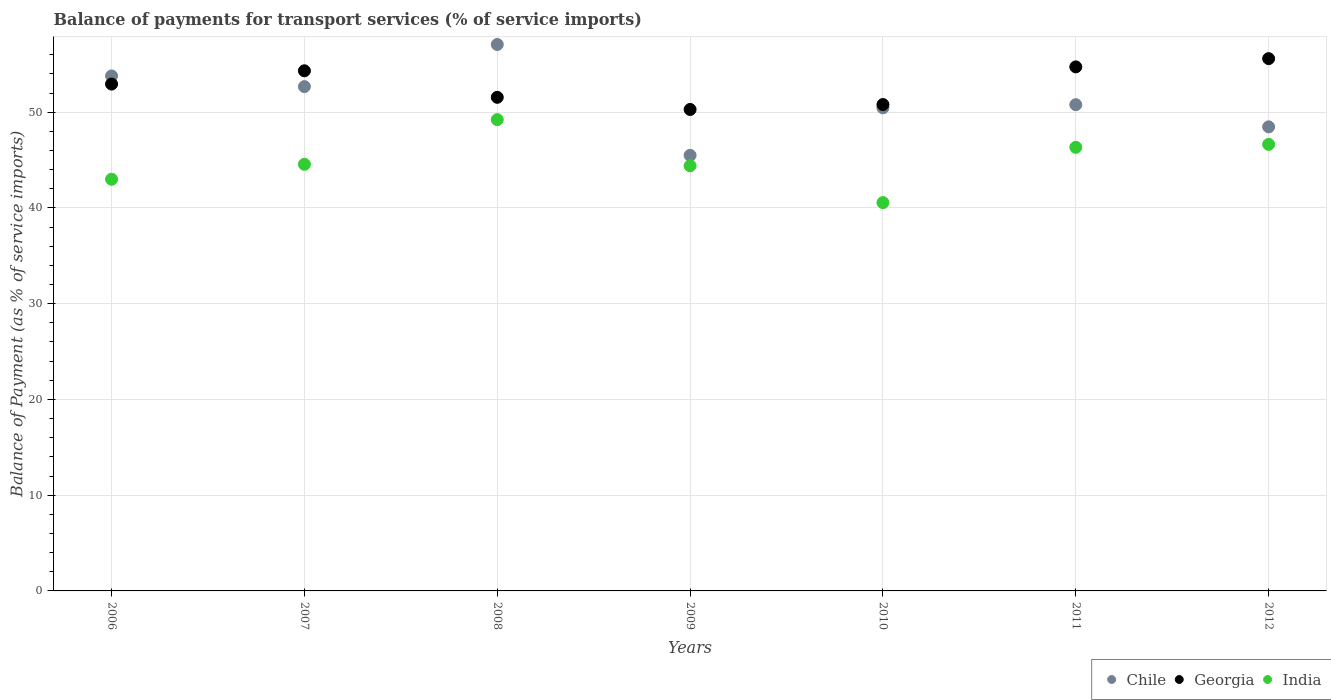How many different coloured dotlines are there?
Keep it short and to the point. 3. Is the number of dotlines equal to the number of legend labels?
Ensure brevity in your answer.  Yes. What is the balance of payments for transport services in Georgia in 2006?
Your answer should be compact. 52.94. Across all years, what is the maximum balance of payments for transport services in Chile?
Offer a terse response. 57.07. Across all years, what is the minimum balance of payments for transport services in Georgia?
Make the answer very short. 50.28. In which year was the balance of payments for transport services in Chile minimum?
Your answer should be compact. 2009. What is the total balance of payments for transport services in India in the graph?
Offer a very short reply. 314.7. What is the difference between the balance of payments for transport services in India in 2006 and that in 2011?
Make the answer very short. -3.33. What is the difference between the balance of payments for transport services in India in 2011 and the balance of payments for transport services in Georgia in 2012?
Provide a short and direct response. -9.26. What is the average balance of payments for transport services in Georgia per year?
Offer a terse response. 52.89. In the year 2010, what is the difference between the balance of payments for transport services in India and balance of payments for transport services in Georgia?
Provide a succinct answer. -10.24. In how many years, is the balance of payments for transport services in India greater than 6 %?
Provide a succinct answer. 7. What is the ratio of the balance of payments for transport services in India in 2009 to that in 2011?
Provide a succinct answer. 0.96. What is the difference between the highest and the second highest balance of payments for transport services in Chile?
Offer a terse response. 3.29. What is the difference between the highest and the lowest balance of payments for transport services in Chile?
Your answer should be compact. 11.58. Is the sum of the balance of payments for transport services in India in 2006 and 2011 greater than the maximum balance of payments for transport services in Georgia across all years?
Make the answer very short. Yes. Does the balance of payments for transport services in India monotonically increase over the years?
Provide a succinct answer. No. Is the balance of payments for transport services in Chile strictly greater than the balance of payments for transport services in Georgia over the years?
Offer a terse response. No. Is the balance of payments for transport services in India strictly less than the balance of payments for transport services in Chile over the years?
Ensure brevity in your answer.  Yes. How many dotlines are there?
Provide a succinct answer. 3. How many years are there in the graph?
Offer a very short reply. 7. What is the difference between two consecutive major ticks on the Y-axis?
Offer a terse response. 10. Are the values on the major ticks of Y-axis written in scientific E-notation?
Provide a short and direct response. No. Does the graph contain grids?
Provide a short and direct response. Yes. How are the legend labels stacked?
Give a very brief answer. Horizontal. What is the title of the graph?
Keep it short and to the point. Balance of payments for transport services (% of service imports). Does "Uganda" appear as one of the legend labels in the graph?
Give a very brief answer. No. What is the label or title of the X-axis?
Provide a succinct answer. Years. What is the label or title of the Y-axis?
Provide a succinct answer. Balance of Payment (as % of service imports). What is the Balance of Payment (as % of service imports) of Chile in 2006?
Ensure brevity in your answer.  53.79. What is the Balance of Payment (as % of service imports) in Georgia in 2006?
Offer a very short reply. 52.94. What is the Balance of Payment (as % of service imports) of India in 2006?
Provide a short and direct response. 43. What is the Balance of Payment (as % of service imports) of Chile in 2007?
Keep it short and to the point. 52.67. What is the Balance of Payment (as % of service imports) of Georgia in 2007?
Ensure brevity in your answer.  54.32. What is the Balance of Payment (as % of service imports) of India in 2007?
Provide a short and direct response. 44.56. What is the Balance of Payment (as % of service imports) of Chile in 2008?
Your answer should be very brief. 57.07. What is the Balance of Payment (as % of service imports) of Georgia in 2008?
Offer a very short reply. 51.55. What is the Balance of Payment (as % of service imports) of India in 2008?
Your answer should be very brief. 49.22. What is the Balance of Payment (as % of service imports) in Chile in 2009?
Your answer should be very brief. 45.49. What is the Balance of Payment (as % of service imports) of Georgia in 2009?
Keep it short and to the point. 50.28. What is the Balance of Payment (as % of service imports) in India in 2009?
Your answer should be compact. 44.4. What is the Balance of Payment (as % of service imports) in Chile in 2010?
Offer a terse response. 50.45. What is the Balance of Payment (as % of service imports) of Georgia in 2010?
Offer a very short reply. 50.8. What is the Balance of Payment (as % of service imports) of India in 2010?
Make the answer very short. 40.56. What is the Balance of Payment (as % of service imports) of Chile in 2011?
Give a very brief answer. 50.78. What is the Balance of Payment (as % of service imports) of Georgia in 2011?
Your response must be concise. 54.73. What is the Balance of Payment (as % of service imports) of India in 2011?
Ensure brevity in your answer.  46.33. What is the Balance of Payment (as % of service imports) of Chile in 2012?
Provide a succinct answer. 48.47. What is the Balance of Payment (as % of service imports) of Georgia in 2012?
Provide a succinct answer. 55.59. What is the Balance of Payment (as % of service imports) in India in 2012?
Provide a short and direct response. 46.64. Across all years, what is the maximum Balance of Payment (as % of service imports) in Chile?
Provide a short and direct response. 57.07. Across all years, what is the maximum Balance of Payment (as % of service imports) of Georgia?
Your answer should be compact. 55.59. Across all years, what is the maximum Balance of Payment (as % of service imports) of India?
Keep it short and to the point. 49.22. Across all years, what is the minimum Balance of Payment (as % of service imports) of Chile?
Your response must be concise. 45.49. Across all years, what is the minimum Balance of Payment (as % of service imports) in Georgia?
Offer a terse response. 50.28. Across all years, what is the minimum Balance of Payment (as % of service imports) of India?
Provide a short and direct response. 40.56. What is the total Balance of Payment (as % of service imports) of Chile in the graph?
Your response must be concise. 358.72. What is the total Balance of Payment (as % of service imports) of Georgia in the graph?
Your answer should be compact. 370.22. What is the total Balance of Payment (as % of service imports) of India in the graph?
Your answer should be compact. 314.7. What is the difference between the Balance of Payment (as % of service imports) of Chile in 2006 and that in 2007?
Provide a short and direct response. 1.11. What is the difference between the Balance of Payment (as % of service imports) of Georgia in 2006 and that in 2007?
Make the answer very short. -1.39. What is the difference between the Balance of Payment (as % of service imports) in India in 2006 and that in 2007?
Make the answer very short. -1.56. What is the difference between the Balance of Payment (as % of service imports) of Chile in 2006 and that in 2008?
Keep it short and to the point. -3.29. What is the difference between the Balance of Payment (as % of service imports) in Georgia in 2006 and that in 2008?
Offer a terse response. 1.38. What is the difference between the Balance of Payment (as % of service imports) of India in 2006 and that in 2008?
Give a very brief answer. -6.23. What is the difference between the Balance of Payment (as % of service imports) in Chile in 2006 and that in 2009?
Give a very brief answer. 8.29. What is the difference between the Balance of Payment (as % of service imports) in Georgia in 2006 and that in 2009?
Your response must be concise. 2.65. What is the difference between the Balance of Payment (as % of service imports) of India in 2006 and that in 2009?
Give a very brief answer. -1.41. What is the difference between the Balance of Payment (as % of service imports) in Chile in 2006 and that in 2010?
Provide a succinct answer. 3.33. What is the difference between the Balance of Payment (as % of service imports) of Georgia in 2006 and that in 2010?
Ensure brevity in your answer.  2.14. What is the difference between the Balance of Payment (as % of service imports) in India in 2006 and that in 2010?
Give a very brief answer. 2.44. What is the difference between the Balance of Payment (as % of service imports) in Chile in 2006 and that in 2011?
Ensure brevity in your answer.  3. What is the difference between the Balance of Payment (as % of service imports) in Georgia in 2006 and that in 2011?
Your response must be concise. -1.8. What is the difference between the Balance of Payment (as % of service imports) in India in 2006 and that in 2011?
Keep it short and to the point. -3.33. What is the difference between the Balance of Payment (as % of service imports) of Chile in 2006 and that in 2012?
Your response must be concise. 5.32. What is the difference between the Balance of Payment (as % of service imports) in Georgia in 2006 and that in 2012?
Give a very brief answer. -2.66. What is the difference between the Balance of Payment (as % of service imports) of India in 2006 and that in 2012?
Provide a succinct answer. -3.64. What is the difference between the Balance of Payment (as % of service imports) in Chile in 2007 and that in 2008?
Provide a short and direct response. -4.4. What is the difference between the Balance of Payment (as % of service imports) in Georgia in 2007 and that in 2008?
Ensure brevity in your answer.  2.77. What is the difference between the Balance of Payment (as % of service imports) of India in 2007 and that in 2008?
Give a very brief answer. -4.67. What is the difference between the Balance of Payment (as % of service imports) of Chile in 2007 and that in 2009?
Offer a terse response. 7.18. What is the difference between the Balance of Payment (as % of service imports) of Georgia in 2007 and that in 2009?
Provide a short and direct response. 4.04. What is the difference between the Balance of Payment (as % of service imports) of India in 2007 and that in 2009?
Provide a short and direct response. 0.15. What is the difference between the Balance of Payment (as % of service imports) of Chile in 2007 and that in 2010?
Provide a succinct answer. 2.22. What is the difference between the Balance of Payment (as % of service imports) in Georgia in 2007 and that in 2010?
Your response must be concise. 3.52. What is the difference between the Balance of Payment (as % of service imports) in India in 2007 and that in 2010?
Ensure brevity in your answer.  4. What is the difference between the Balance of Payment (as % of service imports) of Chile in 2007 and that in 2011?
Offer a very short reply. 1.89. What is the difference between the Balance of Payment (as % of service imports) of Georgia in 2007 and that in 2011?
Your response must be concise. -0.41. What is the difference between the Balance of Payment (as % of service imports) in India in 2007 and that in 2011?
Provide a short and direct response. -1.77. What is the difference between the Balance of Payment (as % of service imports) of Chile in 2007 and that in 2012?
Offer a very short reply. 4.2. What is the difference between the Balance of Payment (as % of service imports) of Georgia in 2007 and that in 2012?
Provide a succinct answer. -1.27. What is the difference between the Balance of Payment (as % of service imports) in India in 2007 and that in 2012?
Make the answer very short. -2.08. What is the difference between the Balance of Payment (as % of service imports) of Chile in 2008 and that in 2009?
Offer a very short reply. 11.58. What is the difference between the Balance of Payment (as % of service imports) of Georgia in 2008 and that in 2009?
Provide a short and direct response. 1.27. What is the difference between the Balance of Payment (as % of service imports) of India in 2008 and that in 2009?
Offer a terse response. 4.82. What is the difference between the Balance of Payment (as % of service imports) of Chile in 2008 and that in 2010?
Offer a terse response. 6.62. What is the difference between the Balance of Payment (as % of service imports) in Georgia in 2008 and that in 2010?
Provide a succinct answer. 0.75. What is the difference between the Balance of Payment (as % of service imports) of India in 2008 and that in 2010?
Offer a very short reply. 8.67. What is the difference between the Balance of Payment (as % of service imports) of Chile in 2008 and that in 2011?
Your answer should be compact. 6.29. What is the difference between the Balance of Payment (as % of service imports) of Georgia in 2008 and that in 2011?
Offer a terse response. -3.18. What is the difference between the Balance of Payment (as % of service imports) of India in 2008 and that in 2011?
Provide a short and direct response. 2.89. What is the difference between the Balance of Payment (as % of service imports) in Chile in 2008 and that in 2012?
Offer a very short reply. 8.6. What is the difference between the Balance of Payment (as % of service imports) in Georgia in 2008 and that in 2012?
Make the answer very short. -4.04. What is the difference between the Balance of Payment (as % of service imports) of India in 2008 and that in 2012?
Make the answer very short. 2.58. What is the difference between the Balance of Payment (as % of service imports) of Chile in 2009 and that in 2010?
Offer a very short reply. -4.96. What is the difference between the Balance of Payment (as % of service imports) of Georgia in 2009 and that in 2010?
Your answer should be compact. -0.51. What is the difference between the Balance of Payment (as % of service imports) in India in 2009 and that in 2010?
Give a very brief answer. 3.85. What is the difference between the Balance of Payment (as % of service imports) in Chile in 2009 and that in 2011?
Offer a very short reply. -5.29. What is the difference between the Balance of Payment (as % of service imports) of Georgia in 2009 and that in 2011?
Your answer should be very brief. -4.45. What is the difference between the Balance of Payment (as % of service imports) of India in 2009 and that in 2011?
Your answer should be very brief. -1.93. What is the difference between the Balance of Payment (as % of service imports) in Chile in 2009 and that in 2012?
Offer a very short reply. -2.98. What is the difference between the Balance of Payment (as % of service imports) in Georgia in 2009 and that in 2012?
Your response must be concise. -5.31. What is the difference between the Balance of Payment (as % of service imports) of India in 2009 and that in 2012?
Ensure brevity in your answer.  -2.24. What is the difference between the Balance of Payment (as % of service imports) in Chile in 2010 and that in 2011?
Offer a very short reply. -0.33. What is the difference between the Balance of Payment (as % of service imports) of Georgia in 2010 and that in 2011?
Your response must be concise. -3.93. What is the difference between the Balance of Payment (as % of service imports) of India in 2010 and that in 2011?
Offer a terse response. -5.77. What is the difference between the Balance of Payment (as % of service imports) in Chile in 2010 and that in 2012?
Your answer should be compact. 1.98. What is the difference between the Balance of Payment (as % of service imports) in Georgia in 2010 and that in 2012?
Keep it short and to the point. -4.8. What is the difference between the Balance of Payment (as % of service imports) in India in 2010 and that in 2012?
Your answer should be compact. -6.08. What is the difference between the Balance of Payment (as % of service imports) of Chile in 2011 and that in 2012?
Provide a short and direct response. 2.32. What is the difference between the Balance of Payment (as % of service imports) of Georgia in 2011 and that in 2012?
Provide a short and direct response. -0.86. What is the difference between the Balance of Payment (as % of service imports) of India in 2011 and that in 2012?
Your answer should be compact. -0.31. What is the difference between the Balance of Payment (as % of service imports) in Chile in 2006 and the Balance of Payment (as % of service imports) in Georgia in 2007?
Ensure brevity in your answer.  -0.54. What is the difference between the Balance of Payment (as % of service imports) in Chile in 2006 and the Balance of Payment (as % of service imports) in India in 2007?
Keep it short and to the point. 9.23. What is the difference between the Balance of Payment (as % of service imports) of Georgia in 2006 and the Balance of Payment (as % of service imports) of India in 2007?
Ensure brevity in your answer.  8.38. What is the difference between the Balance of Payment (as % of service imports) in Chile in 2006 and the Balance of Payment (as % of service imports) in Georgia in 2008?
Provide a short and direct response. 2.23. What is the difference between the Balance of Payment (as % of service imports) in Chile in 2006 and the Balance of Payment (as % of service imports) in India in 2008?
Your answer should be compact. 4.56. What is the difference between the Balance of Payment (as % of service imports) of Georgia in 2006 and the Balance of Payment (as % of service imports) of India in 2008?
Offer a terse response. 3.71. What is the difference between the Balance of Payment (as % of service imports) of Chile in 2006 and the Balance of Payment (as % of service imports) of Georgia in 2009?
Provide a short and direct response. 3.5. What is the difference between the Balance of Payment (as % of service imports) of Chile in 2006 and the Balance of Payment (as % of service imports) of India in 2009?
Make the answer very short. 9.38. What is the difference between the Balance of Payment (as % of service imports) in Georgia in 2006 and the Balance of Payment (as % of service imports) in India in 2009?
Offer a terse response. 8.53. What is the difference between the Balance of Payment (as % of service imports) in Chile in 2006 and the Balance of Payment (as % of service imports) in Georgia in 2010?
Your response must be concise. 2.99. What is the difference between the Balance of Payment (as % of service imports) of Chile in 2006 and the Balance of Payment (as % of service imports) of India in 2010?
Provide a succinct answer. 13.23. What is the difference between the Balance of Payment (as % of service imports) of Georgia in 2006 and the Balance of Payment (as % of service imports) of India in 2010?
Your answer should be very brief. 12.38. What is the difference between the Balance of Payment (as % of service imports) of Chile in 2006 and the Balance of Payment (as % of service imports) of Georgia in 2011?
Ensure brevity in your answer.  -0.95. What is the difference between the Balance of Payment (as % of service imports) in Chile in 2006 and the Balance of Payment (as % of service imports) in India in 2011?
Offer a terse response. 7.46. What is the difference between the Balance of Payment (as % of service imports) in Georgia in 2006 and the Balance of Payment (as % of service imports) in India in 2011?
Your answer should be compact. 6.61. What is the difference between the Balance of Payment (as % of service imports) in Chile in 2006 and the Balance of Payment (as % of service imports) in Georgia in 2012?
Your answer should be compact. -1.81. What is the difference between the Balance of Payment (as % of service imports) in Chile in 2006 and the Balance of Payment (as % of service imports) in India in 2012?
Your answer should be very brief. 7.15. What is the difference between the Balance of Payment (as % of service imports) of Georgia in 2006 and the Balance of Payment (as % of service imports) of India in 2012?
Your response must be concise. 6.3. What is the difference between the Balance of Payment (as % of service imports) in Chile in 2007 and the Balance of Payment (as % of service imports) in Georgia in 2008?
Your answer should be compact. 1.12. What is the difference between the Balance of Payment (as % of service imports) in Chile in 2007 and the Balance of Payment (as % of service imports) in India in 2008?
Your response must be concise. 3.45. What is the difference between the Balance of Payment (as % of service imports) in Georgia in 2007 and the Balance of Payment (as % of service imports) in India in 2008?
Provide a succinct answer. 5.1. What is the difference between the Balance of Payment (as % of service imports) of Chile in 2007 and the Balance of Payment (as % of service imports) of Georgia in 2009?
Give a very brief answer. 2.39. What is the difference between the Balance of Payment (as % of service imports) in Chile in 2007 and the Balance of Payment (as % of service imports) in India in 2009?
Your answer should be compact. 8.27. What is the difference between the Balance of Payment (as % of service imports) of Georgia in 2007 and the Balance of Payment (as % of service imports) of India in 2009?
Ensure brevity in your answer.  9.92. What is the difference between the Balance of Payment (as % of service imports) in Chile in 2007 and the Balance of Payment (as % of service imports) in Georgia in 2010?
Offer a very short reply. 1.87. What is the difference between the Balance of Payment (as % of service imports) of Chile in 2007 and the Balance of Payment (as % of service imports) of India in 2010?
Provide a succinct answer. 12.11. What is the difference between the Balance of Payment (as % of service imports) of Georgia in 2007 and the Balance of Payment (as % of service imports) of India in 2010?
Provide a short and direct response. 13.77. What is the difference between the Balance of Payment (as % of service imports) in Chile in 2007 and the Balance of Payment (as % of service imports) in Georgia in 2011?
Make the answer very short. -2.06. What is the difference between the Balance of Payment (as % of service imports) in Chile in 2007 and the Balance of Payment (as % of service imports) in India in 2011?
Offer a very short reply. 6.34. What is the difference between the Balance of Payment (as % of service imports) in Georgia in 2007 and the Balance of Payment (as % of service imports) in India in 2011?
Give a very brief answer. 7.99. What is the difference between the Balance of Payment (as % of service imports) of Chile in 2007 and the Balance of Payment (as % of service imports) of Georgia in 2012?
Provide a succinct answer. -2.92. What is the difference between the Balance of Payment (as % of service imports) in Chile in 2007 and the Balance of Payment (as % of service imports) in India in 2012?
Offer a very short reply. 6.03. What is the difference between the Balance of Payment (as % of service imports) of Georgia in 2007 and the Balance of Payment (as % of service imports) of India in 2012?
Your response must be concise. 7.68. What is the difference between the Balance of Payment (as % of service imports) of Chile in 2008 and the Balance of Payment (as % of service imports) of Georgia in 2009?
Your answer should be very brief. 6.79. What is the difference between the Balance of Payment (as % of service imports) in Chile in 2008 and the Balance of Payment (as % of service imports) in India in 2009?
Offer a terse response. 12.67. What is the difference between the Balance of Payment (as % of service imports) in Georgia in 2008 and the Balance of Payment (as % of service imports) in India in 2009?
Provide a succinct answer. 7.15. What is the difference between the Balance of Payment (as % of service imports) of Chile in 2008 and the Balance of Payment (as % of service imports) of Georgia in 2010?
Make the answer very short. 6.27. What is the difference between the Balance of Payment (as % of service imports) in Chile in 2008 and the Balance of Payment (as % of service imports) in India in 2010?
Keep it short and to the point. 16.51. What is the difference between the Balance of Payment (as % of service imports) of Georgia in 2008 and the Balance of Payment (as % of service imports) of India in 2010?
Keep it short and to the point. 11. What is the difference between the Balance of Payment (as % of service imports) of Chile in 2008 and the Balance of Payment (as % of service imports) of Georgia in 2011?
Your answer should be very brief. 2.34. What is the difference between the Balance of Payment (as % of service imports) of Chile in 2008 and the Balance of Payment (as % of service imports) of India in 2011?
Make the answer very short. 10.74. What is the difference between the Balance of Payment (as % of service imports) in Georgia in 2008 and the Balance of Payment (as % of service imports) in India in 2011?
Your response must be concise. 5.22. What is the difference between the Balance of Payment (as % of service imports) of Chile in 2008 and the Balance of Payment (as % of service imports) of Georgia in 2012?
Provide a succinct answer. 1.48. What is the difference between the Balance of Payment (as % of service imports) of Chile in 2008 and the Balance of Payment (as % of service imports) of India in 2012?
Provide a short and direct response. 10.43. What is the difference between the Balance of Payment (as % of service imports) of Georgia in 2008 and the Balance of Payment (as % of service imports) of India in 2012?
Make the answer very short. 4.91. What is the difference between the Balance of Payment (as % of service imports) in Chile in 2009 and the Balance of Payment (as % of service imports) in Georgia in 2010?
Offer a very short reply. -5.31. What is the difference between the Balance of Payment (as % of service imports) of Chile in 2009 and the Balance of Payment (as % of service imports) of India in 2010?
Your response must be concise. 4.93. What is the difference between the Balance of Payment (as % of service imports) of Georgia in 2009 and the Balance of Payment (as % of service imports) of India in 2010?
Provide a short and direct response. 9.73. What is the difference between the Balance of Payment (as % of service imports) in Chile in 2009 and the Balance of Payment (as % of service imports) in Georgia in 2011?
Provide a succinct answer. -9.24. What is the difference between the Balance of Payment (as % of service imports) of Chile in 2009 and the Balance of Payment (as % of service imports) of India in 2011?
Your answer should be compact. -0.84. What is the difference between the Balance of Payment (as % of service imports) of Georgia in 2009 and the Balance of Payment (as % of service imports) of India in 2011?
Keep it short and to the point. 3.95. What is the difference between the Balance of Payment (as % of service imports) in Chile in 2009 and the Balance of Payment (as % of service imports) in Georgia in 2012?
Your answer should be very brief. -10.1. What is the difference between the Balance of Payment (as % of service imports) of Chile in 2009 and the Balance of Payment (as % of service imports) of India in 2012?
Provide a short and direct response. -1.15. What is the difference between the Balance of Payment (as % of service imports) of Georgia in 2009 and the Balance of Payment (as % of service imports) of India in 2012?
Your answer should be very brief. 3.64. What is the difference between the Balance of Payment (as % of service imports) of Chile in 2010 and the Balance of Payment (as % of service imports) of Georgia in 2011?
Ensure brevity in your answer.  -4.28. What is the difference between the Balance of Payment (as % of service imports) in Chile in 2010 and the Balance of Payment (as % of service imports) in India in 2011?
Your answer should be compact. 4.12. What is the difference between the Balance of Payment (as % of service imports) in Georgia in 2010 and the Balance of Payment (as % of service imports) in India in 2011?
Provide a succinct answer. 4.47. What is the difference between the Balance of Payment (as % of service imports) in Chile in 2010 and the Balance of Payment (as % of service imports) in Georgia in 2012?
Offer a very short reply. -5.14. What is the difference between the Balance of Payment (as % of service imports) of Chile in 2010 and the Balance of Payment (as % of service imports) of India in 2012?
Offer a terse response. 3.81. What is the difference between the Balance of Payment (as % of service imports) in Georgia in 2010 and the Balance of Payment (as % of service imports) in India in 2012?
Offer a terse response. 4.16. What is the difference between the Balance of Payment (as % of service imports) of Chile in 2011 and the Balance of Payment (as % of service imports) of Georgia in 2012?
Provide a short and direct response. -4.81. What is the difference between the Balance of Payment (as % of service imports) in Chile in 2011 and the Balance of Payment (as % of service imports) in India in 2012?
Make the answer very short. 4.15. What is the difference between the Balance of Payment (as % of service imports) of Georgia in 2011 and the Balance of Payment (as % of service imports) of India in 2012?
Make the answer very short. 8.09. What is the average Balance of Payment (as % of service imports) in Chile per year?
Make the answer very short. 51.25. What is the average Balance of Payment (as % of service imports) in Georgia per year?
Make the answer very short. 52.89. What is the average Balance of Payment (as % of service imports) of India per year?
Keep it short and to the point. 44.96. In the year 2006, what is the difference between the Balance of Payment (as % of service imports) of Chile and Balance of Payment (as % of service imports) of Georgia?
Ensure brevity in your answer.  0.85. In the year 2006, what is the difference between the Balance of Payment (as % of service imports) of Chile and Balance of Payment (as % of service imports) of India?
Ensure brevity in your answer.  10.79. In the year 2006, what is the difference between the Balance of Payment (as % of service imports) of Georgia and Balance of Payment (as % of service imports) of India?
Ensure brevity in your answer.  9.94. In the year 2007, what is the difference between the Balance of Payment (as % of service imports) of Chile and Balance of Payment (as % of service imports) of Georgia?
Your answer should be compact. -1.65. In the year 2007, what is the difference between the Balance of Payment (as % of service imports) in Chile and Balance of Payment (as % of service imports) in India?
Give a very brief answer. 8.11. In the year 2007, what is the difference between the Balance of Payment (as % of service imports) in Georgia and Balance of Payment (as % of service imports) in India?
Give a very brief answer. 9.77. In the year 2008, what is the difference between the Balance of Payment (as % of service imports) of Chile and Balance of Payment (as % of service imports) of Georgia?
Offer a very short reply. 5.52. In the year 2008, what is the difference between the Balance of Payment (as % of service imports) in Chile and Balance of Payment (as % of service imports) in India?
Give a very brief answer. 7.85. In the year 2008, what is the difference between the Balance of Payment (as % of service imports) in Georgia and Balance of Payment (as % of service imports) in India?
Provide a short and direct response. 2.33. In the year 2009, what is the difference between the Balance of Payment (as % of service imports) in Chile and Balance of Payment (as % of service imports) in Georgia?
Offer a very short reply. -4.79. In the year 2009, what is the difference between the Balance of Payment (as % of service imports) in Chile and Balance of Payment (as % of service imports) in India?
Ensure brevity in your answer.  1.09. In the year 2009, what is the difference between the Balance of Payment (as % of service imports) in Georgia and Balance of Payment (as % of service imports) in India?
Your response must be concise. 5.88. In the year 2010, what is the difference between the Balance of Payment (as % of service imports) of Chile and Balance of Payment (as % of service imports) of Georgia?
Your answer should be compact. -0.35. In the year 2010, what is the difference between the Balance of Payment (as % of service imports) in Chile and Balance of Payment (as % of service imports) in India?
Your response must be concise. 9.89. In the year 2010, what is the difference between the Balance of Payment (as % of service imports) in Georgia and Balance of Payment (as % of service imports) in India?
Make the answer very short. 10.24. In the year 2011, what is the difference between the Balance of Payment (as % of service imports) in Chile and Balance of Payment (as % of service imports) in Georgia?
Make the answer very short. -3.95. In the year 2011, what is the difference between the Balance of Payment (as % of service imports) of Chile and Balance of Payment (as % of service imports) of India?
Your answer should be very brief. 4.46. In the year 2011, what is the difference between the Balance of Payment (as % of service imports) in Georgia and Balance of Payment (as % of service imports) in India?
Ensure brevity in your answer.  8.4. In the year 2012, what is the difference between the Balance of Payment (as % of service imports) in Chile and Balance of Payment (as % of service imports) in Georgia?
Provide a succinct answer. -7.13. In the year 2012, what is the difference between the Balance of Payment (as % of service imports) of Chile and Balance of Payment (as % of service imports) of India?
Keep it short and to the point. 1.83. In the year 2012, what is the difference between the Balance of Payment (as % of service imports) in Georgia and Balance of Payment (as % of service imports) in India?
Provide a succinct answer. 8.95. What is the ratio of the Balance of Payment (as % of service imports) in Chile in 2006 to that in 2007?
Your response must be concise. 1.02. What is the ratio of the Balance of Payment (as % of service imports) in Georgia in 2006 to that in 2007?
Offer a very short reply. 0.97. What is the ratio of the Balance of Payment (as % of service imports) of Chile in 2006 to that in 2008?
Your response must be concise. 0.94. What is the ratio of the Balance of Payment (as % of service imports) of Georgia in 2006 to that in 2008?
Offer a terse response. 1.03. What is the ratio of the Balance of Payment (as % of service imports) in India in 2006 to that in 2008?
Provide a succinct answer. 0.87. What is the ratio of the Balance of Payment (as % of service imports) of Chile in 2006 to that in 2009?
Give a very brief answer. 1.18. What is the ratio of the Balance of Payment (as % of service imports) in Georgia in 2006 to that in 2009?
Keep it short and to the point. 1.05. What is the ratio of the Balance of Payment (as % of service imports) in India in 2006 to that in 2009?
Offer a terse response. 0.97. What is the ratio of the Balance of Payment (as % of service imports) in Chile in 2006 to that in 2010?
Provide a short and direct response. 1.07. What is the ratio of the Balance of Payment (as % of service imports) in Georgia in 2006 to that in 2010?
Provide a succinct answer. 1.04. What is the ratio of the Balance of Payment (as % of service imports) of India in 2006 to that in 2010?
Your answer should be very brief. 1.06. What is the ratio of the Balance of Payment (as % of service imports) of Chile in 2006 to that in 2011?
Offer a very short reply. 1.06. What is the ratio of the Balance of Payment (as % of service imports) in Georgia in 2006 to that in 2011?
Offer a very short reply. 0.97. What is the ratio of the Balance of Payment (as % of service imports) in India in 2006 to that in 2011?
Offer a terse response. 0.93. What is the ratio of the Balance of Payment (as % of service imports) of Chile in 2006 to that in 2012?
Your answer should be very brief. 1.11. What is the ratio of the Balance of Payment (as % of service imports) in Georgia in 2006 to that in 2012?
Provide a succinct answer. 0.95. What is the ratio of the Balance of Payment (as % of service imports) of India in 2006 to that in 2012?
Provide a short and direct response. 0.92. What is the ratio of the Balance of Payment (as % of service imports) in Chile in 2007 to that in 2008?
Your response must be concise. 0.92. What is the ratio of the Balance of Payment (as % of service imports) in Georgia in 2007 to that in 2008?
Make the answer very short. 1.05. What is the ratio of the Balance of Payment (as % of service imports) of India in 2007 to that in 2008?
Provide a succinct answer. 0.91. What is the ratio of the Balance of Payment (as % of service imports) of Chile in 2007 to that in 2009?
Provide a short and direct response. 1.16. What is the ratio of the Balance of Payment (as % of service imports) of Georgia in 2007 to that in 2009?
Your answer should be compact. 1.08. What is the ratio of the Balance of Payment (as % of service imports) of India in 2007 to that in 2009?
Your answer should be compact. 1. What is the ratio of the Balance of Payment (as % of service imports) in Chile in 2007 to that in 2010?
Make the answer very short. 1.04. What is the ratio of the Balance of Payment (as % of service imports) of Georgia in 2007 to that in 2010?
Provide a short and direct response. 1.07. What is the ratio of the Balance of Payment (as % of service imports) in India in 2007 to that in 2010?
Ensure brevity in your answer.  1.1. What is the ratio of the Balance of Payment (as % of service imports) of Chile in 2007 to that in 2011?
Give a very brief answer. 1.04. What is the ratio of the Balance of Payment (as % of service imports) of India in 2007 to that in 2011?
Give a very brief answer. 0.96. What is the ratio of the Balance of Payment (as % of service imports) of Chile in 2007 to that in 2012?
Provide a succinct answer. 1.09. What is the ratio of the Balance of Payment (as % of service imports) in Georgia in 2007 to that in 2012?
Ensure brevity in your answer.  0.98. What is the ratio of the Balance of Payment (as % of service imports) in India in 2007 to that in 2012?
Your response must be concise. 0.96. What is the ratio of the Balance of Payment (as % of service imports) in Chile in 2008 to that in 2009?
Offer a very short reply. 1.25. What is the ratio of the Balance of Payment (as % of service imports) of Georgia in 2008 to that in 2009?
Keep it short and to the point. 1.03. What is the ratio of the Balance of Payment (as % of service imports) in India in 2008 to that in 2009?
Keep it short and to the point. 1.11. What is the ratio of the Balance of Payment (as % of service imports) of Chile in 2008 to that in 2010?
Provide a succinct answer. 1.13. What is the ratio of the Balance of Payment (as % of service imports) in Georgia in 2008 to that in 2010?
Offer a very short reply. 1.01. What is the ratio of the Balance of Payment (as % of service imports) of India in 2008 to that in 2010?
Provide a succinct answer. 1.21. What is the ratio of the Balance of Payment (as % of service imports) of Chile in 2008 to that in 2011?
Your answer should be very brief. 1.12. What is the ratio of the Balance of Payment (as % of service imports) of Georgia in 2008 to that in 2011?
Keep it short and to the point. 0.94. What is the ratio of the Balance of Payment (as % of service imports) of Chile in 2008 to that in 2012?
Your answer should be compact. 1.18. What is the ratio of the Balance of Payment (as % of service imports) in Georgia in 2008 to that in 2012?
Give a very brief answer. 0.93. What is the ratio of the Balance of Payment (as % of service imports) in India in 2008 to that in 2012?
Your response must be concise. 1.06. What is the ratio of the Balance of Payment (as % of service imports) of Chile in 2009 to that in 2010?
Provide a short and direct response. 0.9. What is the ratio of the Balance of Payment (as % of service imports) of Georgia in 2009 to that in 2010?
Your answer should be very brief. 0.99. What is the ratio of the Balance of Payment (as % of service imports) in India in 2009 to that in 2010?
Offer a very short reply. 1.09. What is the ratio of the Balance of Payment (as % of service imports) in Chile in 2009 to that in 2011?
Make the answer very short. 0.9. What is the ratio of the Balance of Payment (as % of service imports) in Georgia in 2009 to that in 2011?
Offer a terse response. 0.92. What is the ratio of the Balance of Payment (as % of service imports) in India in 2009 to that in 2011?
Your answer should be compact. 0.96. What is the ratio of the Balance of Payment (as % of service imports) of Chile in 2009 to that in 2012?
Keep it short and to the point. 0.94. What is the ratio of the Balance of Payment (as % of service imports) in Georgia in 2009 to that in 2012?
Offer a terse response. 0.9. What is the ratio of the Balance of Payment (as % of service imports) of India in 2009 to that in 2012?
Your response must be concise. 0.95. What is the ratio of the Balance of Payment (as % of service imports) of Georgia in 2010 to that in 2011?
Your answer should be compact. 0.93. What is the ratio of the Balance of Payment (as % of service imports) in India in 2010 to that in 2011?
Provide a succinct answer. 0.88. What is the ratio of the Balance of Payment (as % of service imports) in Chile in 2010 to that in 2012?
Offer a very short reply. 1.04. What is the ratio of the Balance of Payment (as % of service imports) in Georgia in 2010 to that in 2012?
Your answer should be compact. 0.91. What is the ratio of the Balance of Payment (as % of service imports) of India in 2010 to that in 2012?
Make the answer very short. 0.87. What is the ratio of the Balance of Payment (as % of service imports) of Chile in 2011 to that in 2012?
Offer a terse response. 1.05. What is the ratio of the Balance of Payment (as % of service imports) in Georgia in 2011 to that in 2012?
Offer a very short reply. 0.98. What is the ratio of the Balance of Payment (as % of service imports) of India in 2011 to that in 2012?
Offer a very short reply. 0.99. What is the difference between the highest and the second highest Balance of Payment (as % of service imports) in Chile?
Provide a succinct answer. 3.29. What is the difference between the highest and the second highest Balance of Payment (as % of service imports) of Georgia?
Offer a very short reply. 0.86. What is the difference between the highest and the second highest Balance of Payment (as % of service imports) of India?
Make the answer very short. 2.58. What is the difference between the highest and the lowest Balance of Payment (as % of service imports) in Chile?
Provide a succinct answer. 11.58. What is the difference between the highest and the lowest Balance of Payment (as % of service imports) of Georgia?
Offer a terse response. 5.31. What is the difference between the highest and the lowest Balance of Payment (as % of service imports) of India?
Provide a short and direct response. 8.67. 